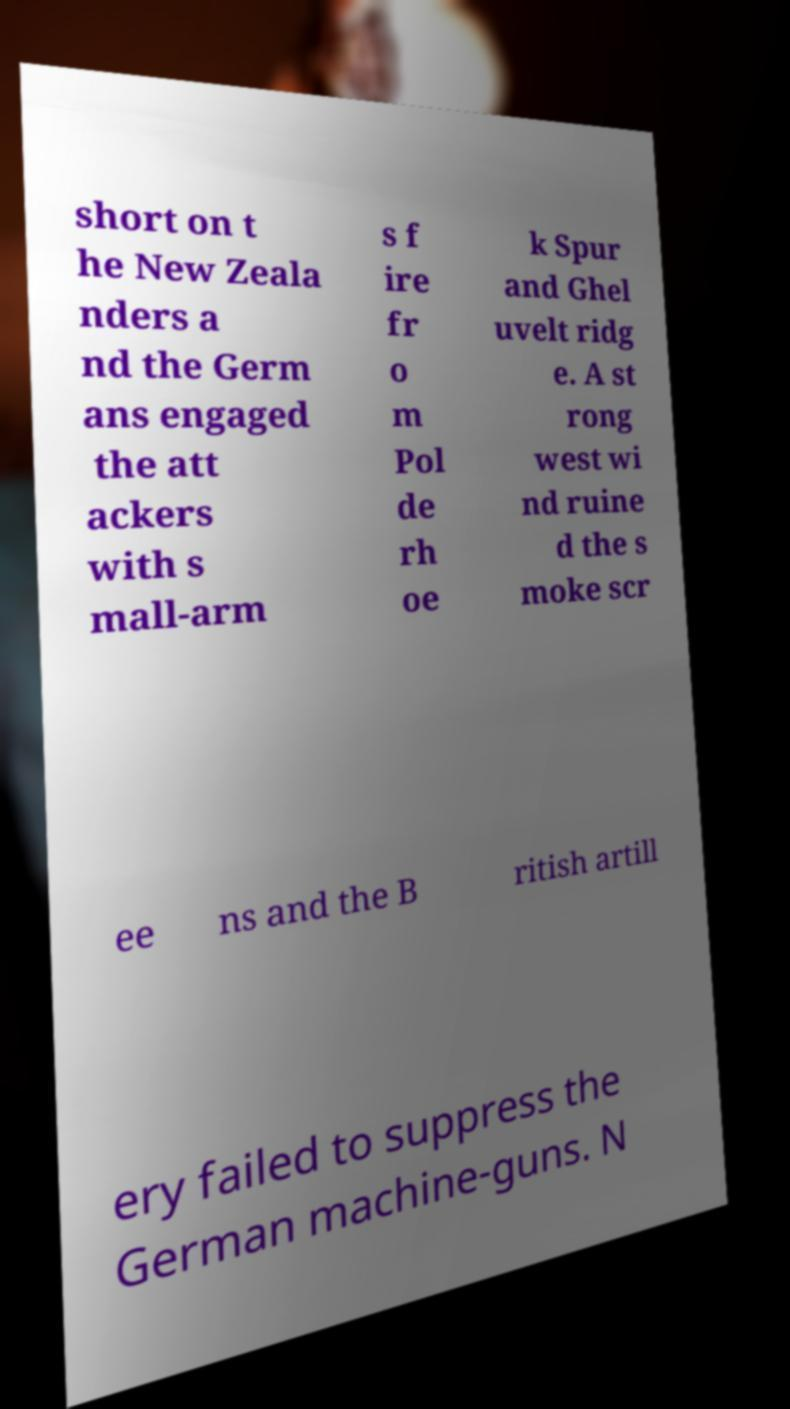Can you read and provide the text displayed in the image?This photo seems to have some interesting text. Can you extract and type it out for me? short on t he New Zeala nders a nd the Germ ans engaged the att ackers with s mall-arm s f ire fr o m Pol de rh oe k Spur and Ghel uvelt ridg e. A st rong west wi nd ruine d the s moke scr ee ns and the B ritish artill ery failed to suppress the German machine-guns. N 